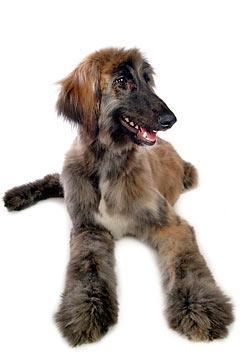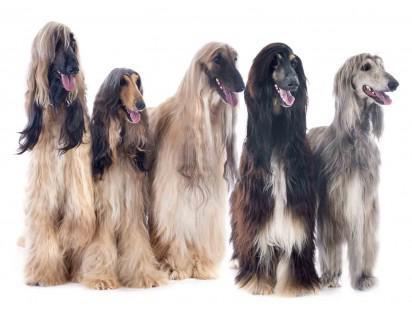The first image is the image on the left, the second image is the image on the right. Examine the images to the left and right. Is the description "An image shows exactly one dog standing on all fours, and its fur is wavy-textured and dark grayish with paler markings." accurate? Answer yes or no. No. The first image is the image on the left, the second image is the image on the right. For the images shown, is this caption "A dog in one of the images is lying down." true? Answer yes or no. Yes. 